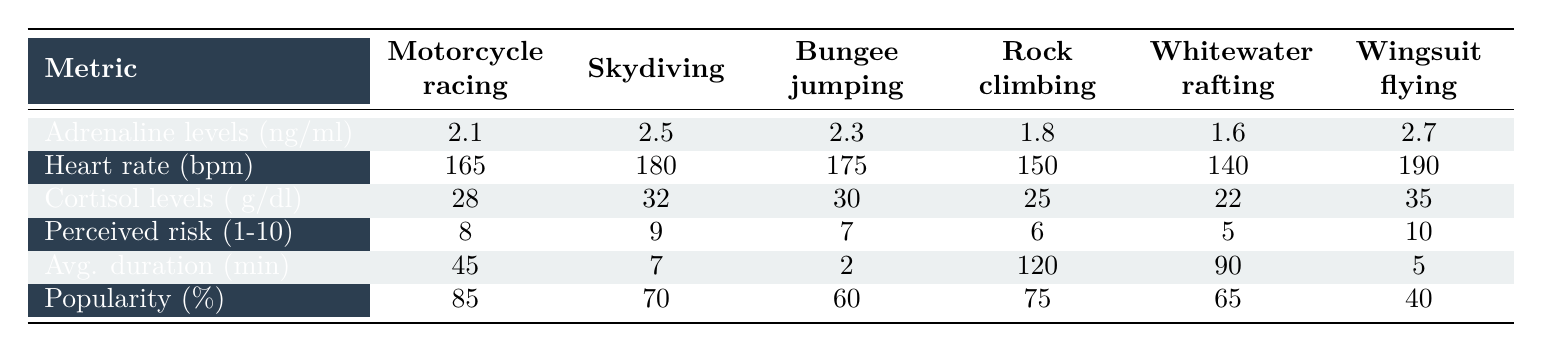What is the highest perceived risk on the scale of 1 to 10 among the activities listed? The perceived risk for Wingsuit flying is 10, which is the highest value when compared to all other activities listed.
Answer: 10 Which activity has the lowest cortisol levels? The activity with the lowest cortisol level is Whitewater rafting, with a cortisol level of 22 μg/dl, which is lower than all other activities.
Answer: 22 μg/dl Calculate the average adrenaline level across all the activities. To find the average adrenaline level, sum the values (2.1 + 2.5 + 2.3 + 1.8 + 1.6 + 2.7 = 12.0) and divide by the number of activities (6). The average is 12.0 / 6 = 2.0 ng/ml.
Answer: 2.0 ng/ml Is the heart rate during Bungee jumping higher than during Whitewater rafting? The heart rate during Bungee jumping is 175 bpm, and for Whitewater rafting, it's 140 bpm. Since 175 is greater than 140, the answer is yes.
Answer: Yes Which activity has the shortest average duration, and what is that duration? Comparing the average duration, Bungee jumping has the shortest duration of 2 minutes.
Answer: 2 minutes What is the difference in popularity percentage between Motorcycle racing and Wingsuit flying? The popularity of Motorcycle racing is 85% and that of Wingsuit flying is 40%. The difference is 85 - 40 = 45%.
Answer: 45% Identify the activity with the highest heart rate and state that heart rate. Wingsuit flying has the highest heart rate of 190 bpm, which is greater than all other activities in the list.
Answer: 190 bpm Which two activities have cortisol levels of 30 μg/dl or higher? The activities with cortisol levels of 30 μg/dl or higher are Skydiving (32 μg/dl) and Bungee jumping (30 μg/dl), as they both meet the criteria.
Answer: Skydiving and Bungee jumping If you arrange the activities by their perceived risk from highest to lowest, which activity would rank third? Arranging the perceived risks (10, 9, 8, 7, 6, 5), Wingsuit flying ranks 1st, Skydiving 2nd, and Motorcycle racing 3rd.
Answer: Motorcycle racing What is the average popularity among the activities listed? The average popularity can be calculated by summing the popularity percentages (85 + 70 + 60 + 75 + 65 + 40 = 395) and dividing by the number of activities (6). The average is 395 / 6 = 65.83%.
Answer: 65.83% 